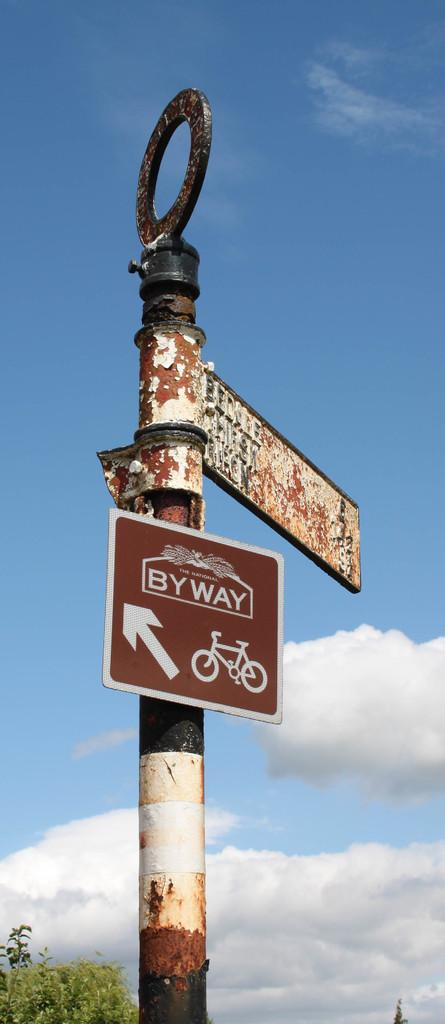What is located in the foreground of the image? There is a signboard pole in the foreground of the image. What can be seen in the background of the image? There is a tree and the sky visible in the background of the image. What is the condition of the sky in the image? The sky is visible in the background of the image, and there are clouds present. What type of canvas is being used by the goat in the image? There is no goat present in the image, and therefore no canvas or related activity can be observed. 